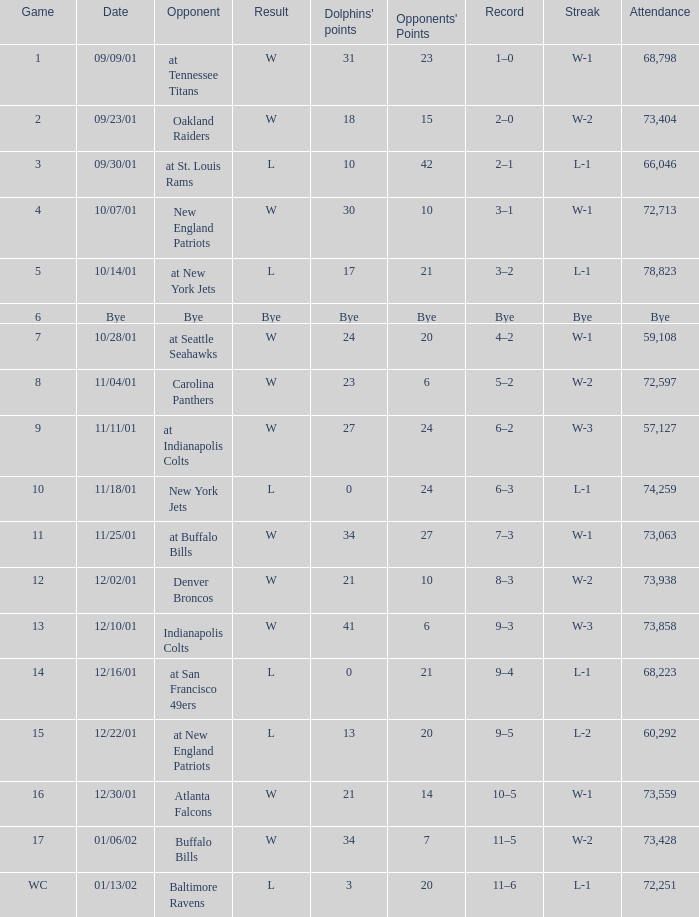Which opponent had 73,428 in attendance? Buffalo Bills. Could you help me parse every detail presented in this table? {'header': ['Game', 'Date', 'Opponent', 'Result', "Dolphins' points", "Opponents' Points", 'Record', 'Streak', 'Attendance'], 'rows': [['1', '09/09/01', 'at Tennessee Titans', 'W', '31', '23', '1–0', 'W-1', '68,798'], ['2', '09/23/01', 'Oakland Raiders', 'W', '18', '15', '2–0', 'W-2', '73,404'], ['3', '09/30/01', 'at St. Louis Rams', 'L', '10', '42', '2–1', 'L-1', '66,046'], ['4', '10/07/01', 'New England Patriots', 'W', '30', '10', '3–1', 'W-1', '72,713'], ['5', '10/14/01', 'at New York Jets', 'L', '17', '21', '3–2', 'L-1', '78,823'], ['6', 'Bye', 'Bye', 'Bye', 'Bye', 'Bye', 'Bye', 'Bye', 'Bye'], ['7', '10/28/01', 'at Seattle Seahawks', 'W', '24', '20', '4–2', 'W-1', '59,108'], ['8', '11/04/01', 'Carolina Panthers', 'W', '23', '6', '5–2', 'W-2', '72,597'], ['9', '11/11/01', 'at Indianapolis Colts', 'W', '27', '24', '6–2', 'W-3', '57,127'], ['10', '11/18/01', 'New York Jets', 'L', '0', '24', '6–3', 'L-1', '74,259'], ['11', '11/25/01', 'at Buffalo Bills', 'W', '34', '27', '7–3', 'W-1', '73,063'], ['12', '12/02/01', 'Denver Broncos', 'W', '21', '10', '8–3', 'W-2', '73,938'], ['13', '12/10/01', 'Indianapolis Colts', 'W', '41', '6', '9–3', 'W-3', '73,858'], ['14', '12/16/01', 'at San Francisco 49ers', 'L', '0', '21', '9–4', 'L-1', '68,223'], ['15', '12/22/01', 'at New England Patriots', 'L', '13', '20', '9–5', 'L-2', '60,292'], ['16', '12/30/01', 'Atlanta Falcons', 'W', '21', '14', '10–5', 'W-1', '73,559'], ['17', '01/06/02', 'Buffalo Bills', 'W', '34', '7', '11–5', 'W-2', '73,428'], ['WC', '01/13/02', 'Baltimore Ravens', 'L', '3', '20', '11–6', 'L-1', '72,251']]} 